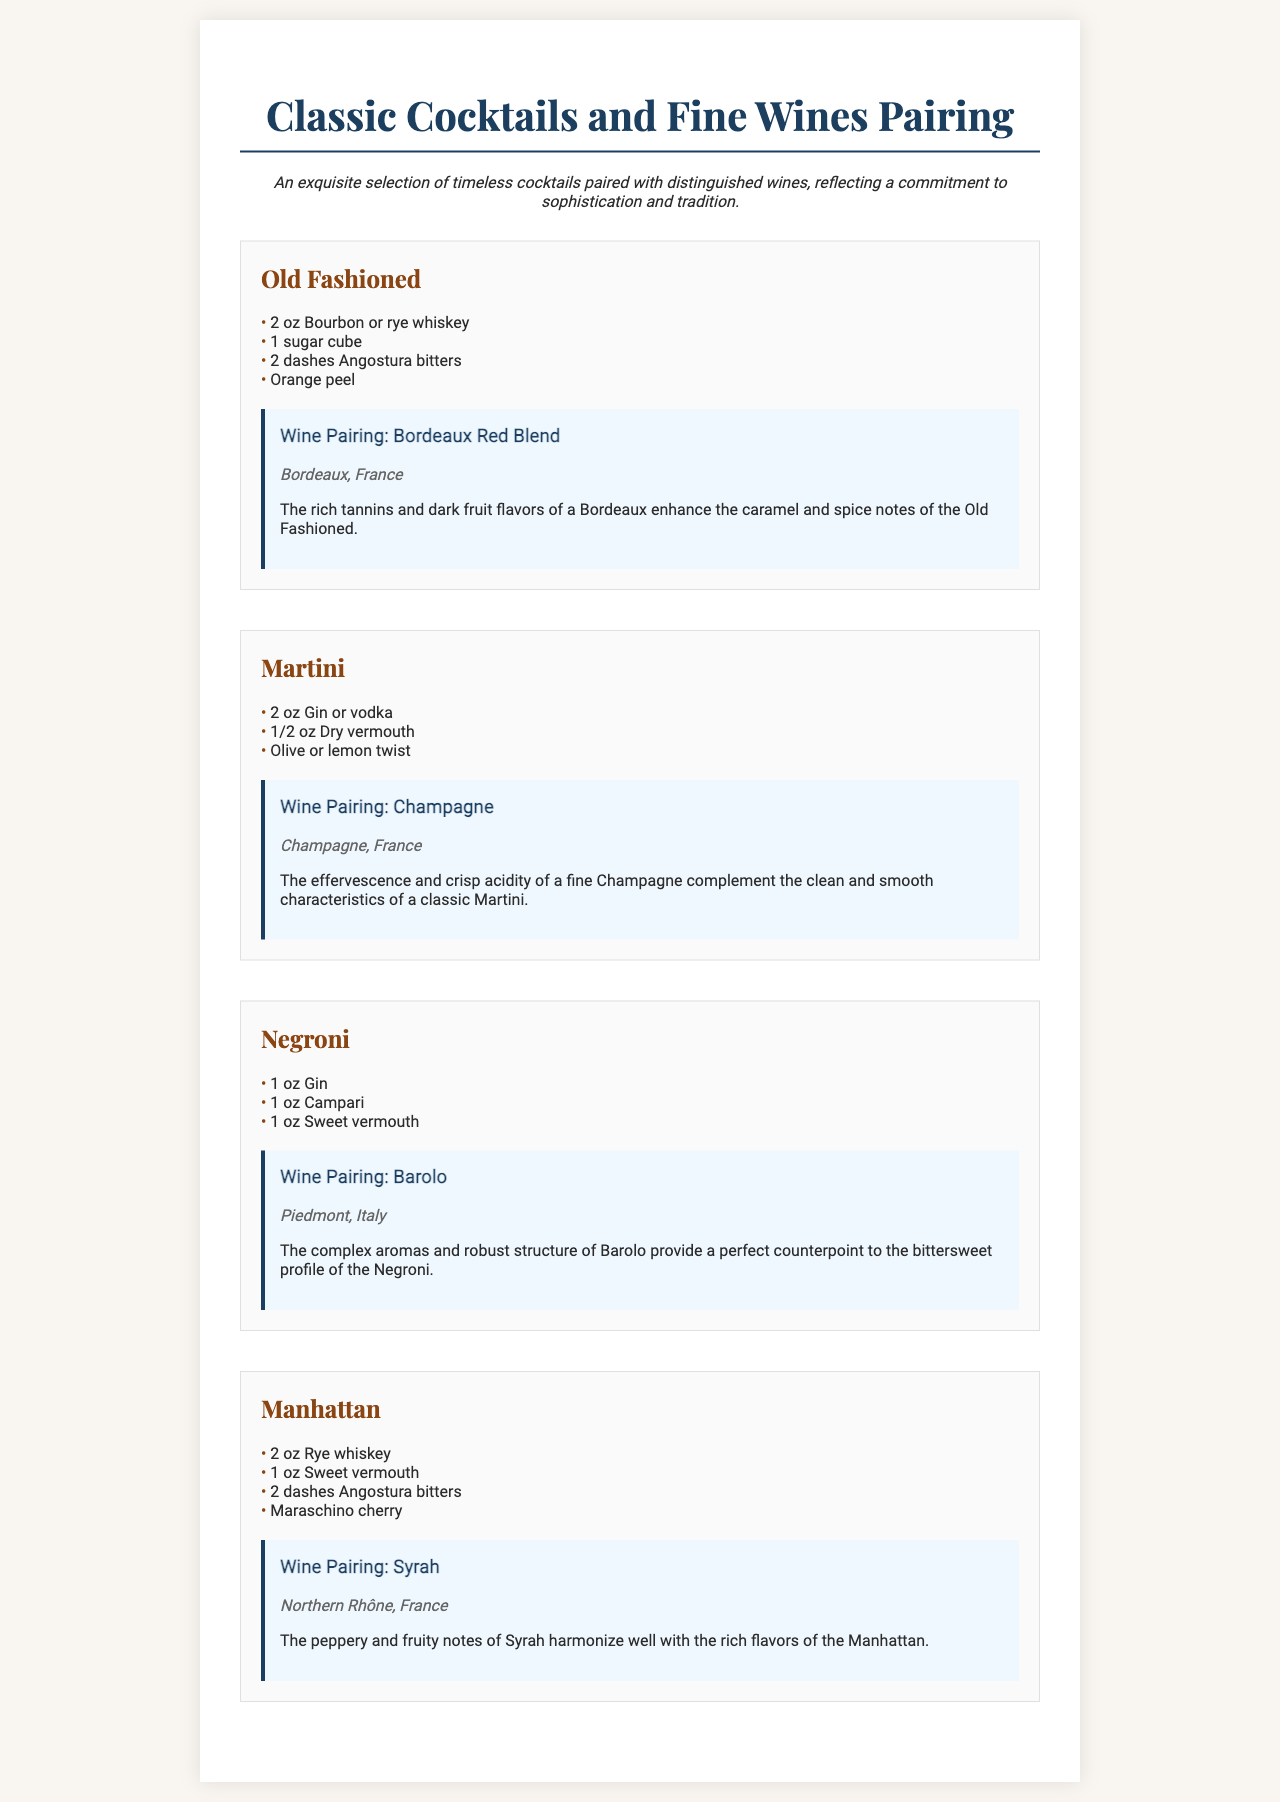What is the main theme of the menu? The description at the top of the menu highlights the theme as a selection of timeless cocktails paired with distinguished wines.
Answer: Timeless cocktails and distinguished wines How many classic cocktails are listed? There are four cocktails presented in the menu section.
Answer: Four What is the primary spirit used in an Old Fashioned? The ingredients for an Old Fashioned list bourbon or rye whiskey as the main spirit.
Answer: Bourbon or rye whiskey Which wine pairs with the Martini? The pairing section explicitly states that Champagne is the wine paired with a Martini.
Answer: Champagne What is the origin of the wine paired with the Negroni? The wine pairing for the Negroni mentions Barolo from Piedmont, Italy.
Answer: Piedmont, Italy How many dashes of bitters are used in a Manhattan? The ingredients for a Manhattan include two dashes of Angostura bitters.
Answer: Two dashes What flavor profile of Barolo complements the Negroni? The pairing description notes that Barolo's complex aromas provide a counterpoint to the Negroni's bittersweet profile.
Answer: Complex aromas and robust structure What garnish is included in a Manhattan? The ingredients list specifies a maraschino cherry as the garnish for a Manhattan.
Answer: Maraschino cherry 